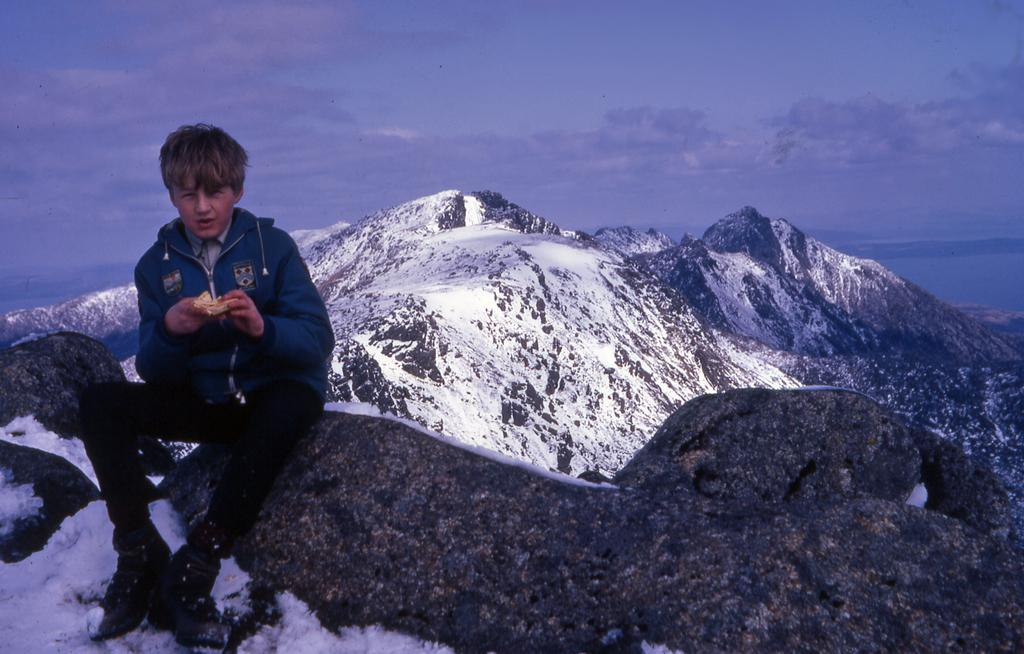What is the person in the image doing? The person is sitting on a rock in the image. What type of landscape can be seen in the image? There are mountains and water visible in the image. What is the weather like in the image? There is snow and clouds present in the sky, indicating a cold and possibly overcast day. What is visible in the background of the image? The sky is visible in the background of the image. What type of farm animals can be seen grazing in the image? There is no farm or farm animals present in the image; it features a person sitting on a rock in a mountainous landscape with snow and water. 